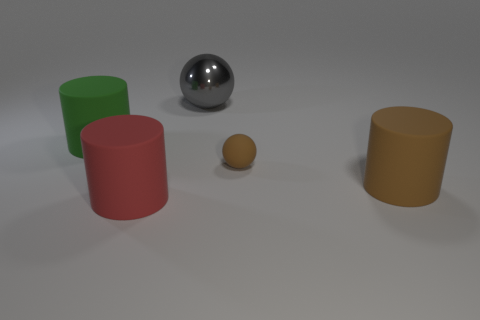Is the shape of the big red rubber thing the same as the large rubber thing on the right side of the gray thing?
Give a very brief answer. Yes. There is a rubber thing that is on the right side of the shiny object and behind the large brown cylinder; what is its size?
Provide a short and direct response. Small. What is the shape of the large metal object?
Ensure brevity in your answer.  Sphere. There is a thing that is in front of the big brown matte object; are there any tiny rubber things that are to the left of it?
Make the answer very short. No. There is a big cylinder that is behind the small sphere; what number of rubber things are behind it?
Offer a very short reply. 0. There is a sphere that is the same size as the red cylinder; what material is it?
Offer a terse response. Metal. There is a big object that is behind the big green cylinder; is it the same shape as the small rubber object?
Your answer should be very brief. Yes. Are there more green rubber things left of the green rubber cylinder than gray metallic balls to the right of the big gray metallic thing?
Give a very brief answer. No. How many brown cylinders have the same material as the large green cylinder?
Provide a succinct answer. 1. Does the gray thing have the same size as the matte sphere?
Offer a very short reply. No. 